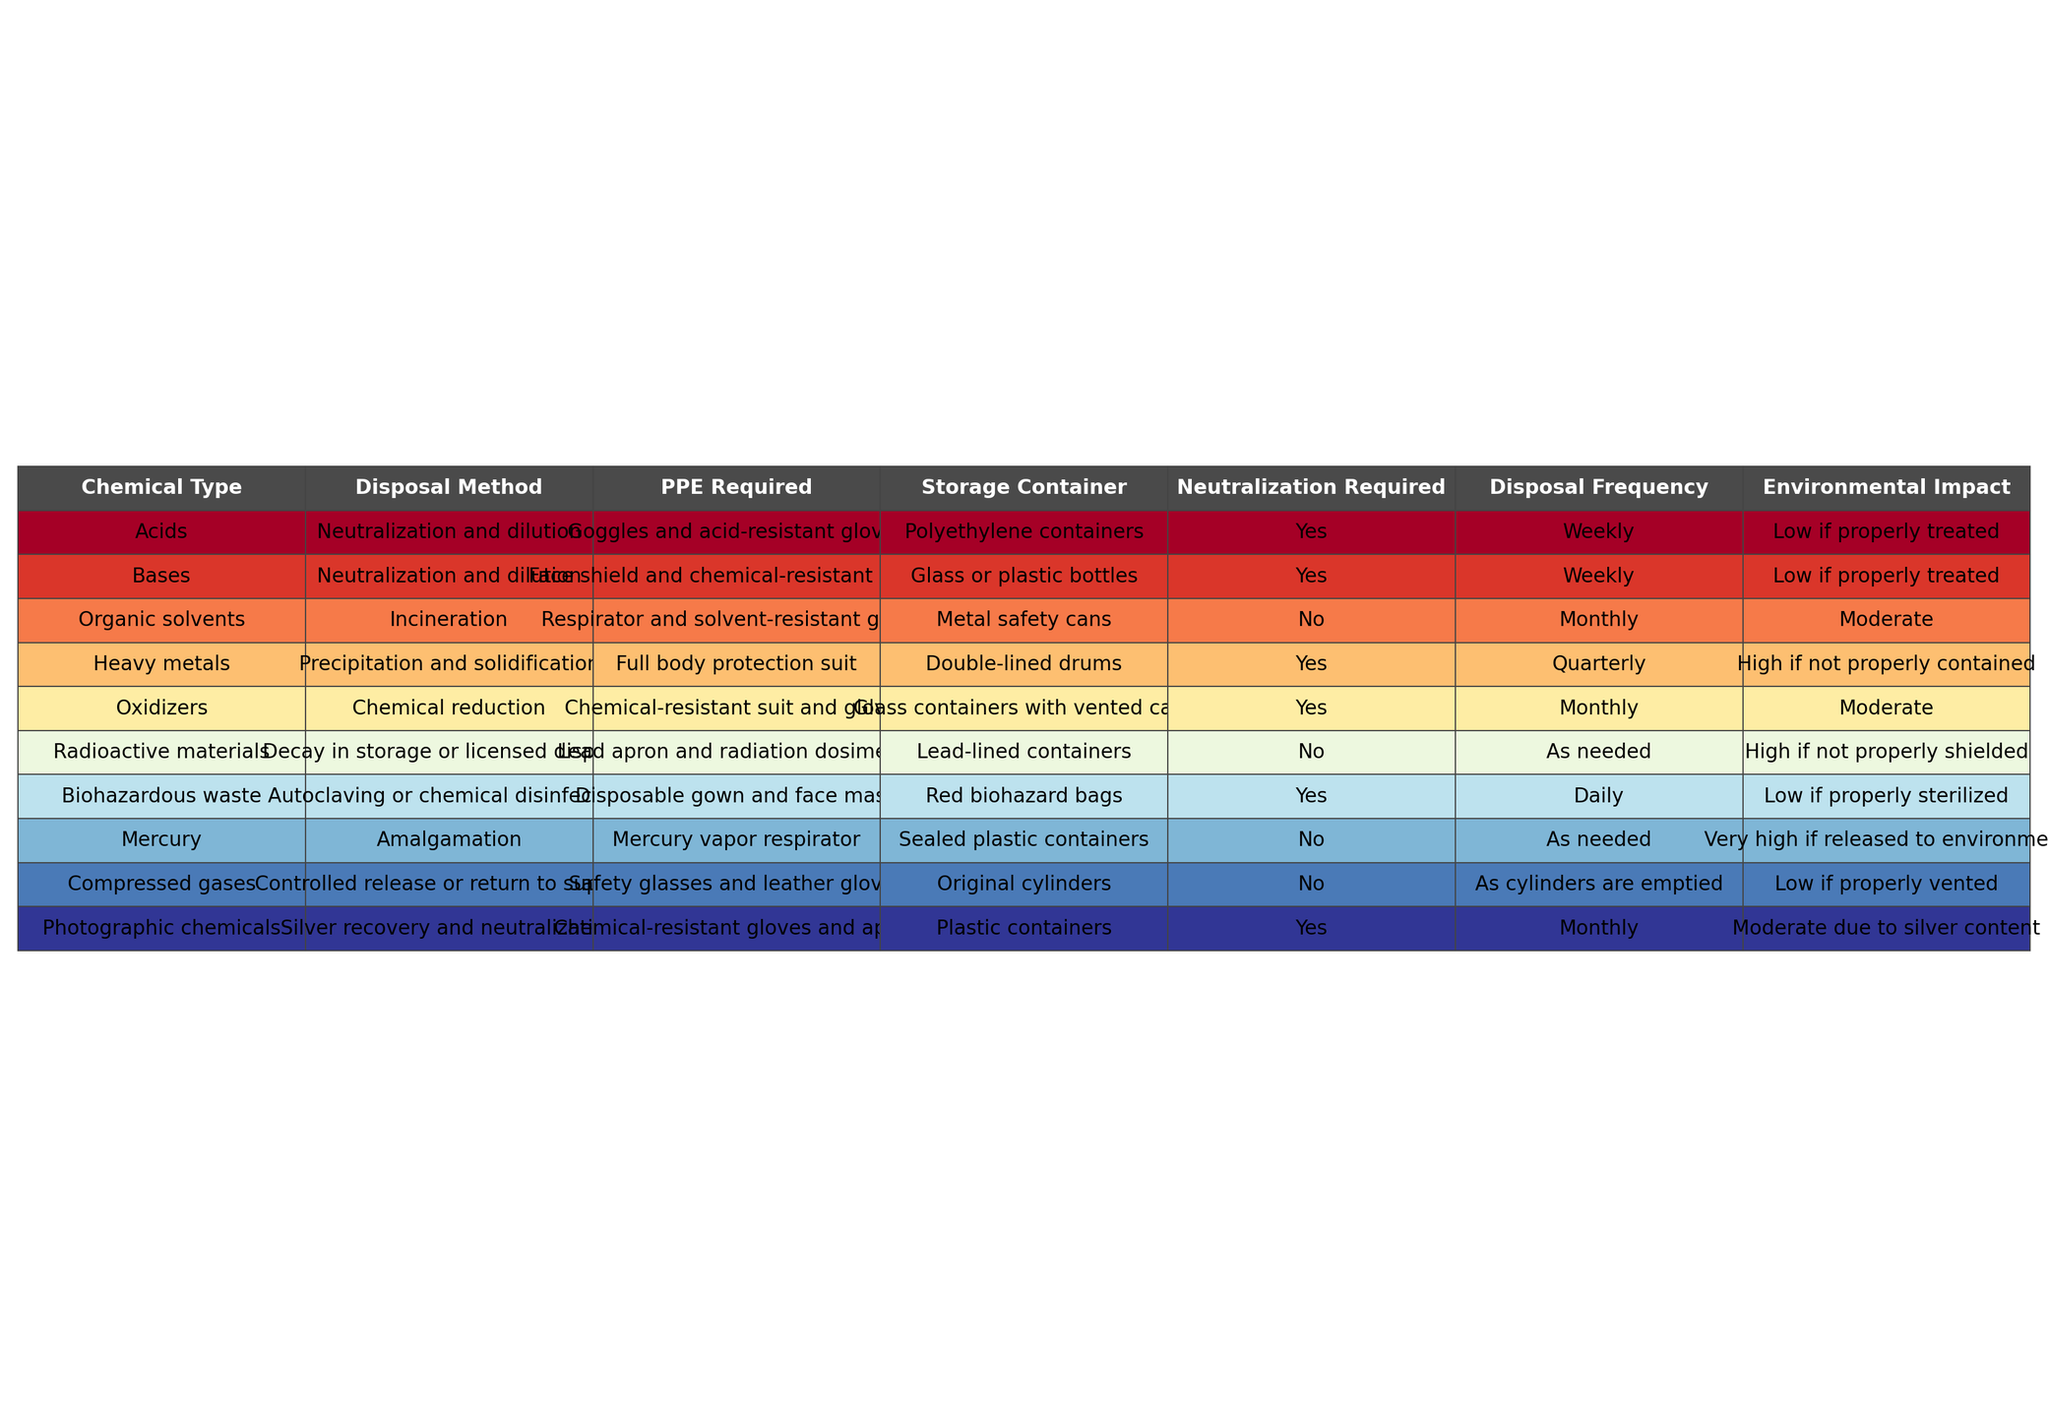What disposal method is used for organic solvents? The table indicates that organic solvents are disposed of through incineration.
Answer: Incineration What is the required PPE for handling heavy metals? The table lists that heavy metals require a full body protection suit as personal protective equipment.
Answer: Full body protection suit How often should acids be disposed of? According to the table, acids need to be disposed of weekly.
Answer: Weekly Are any disposal methods listed as requiring neutralization? The table shows that several chemicals, including acids, bases, oxidizers, and biohazardous waste, require neutralization as part of their disposal methods.
Answer: Yes Which type of chemical has the highest environmental impact if not properly contained? The table states that heavy metals have a high environmental impact if not properly contained.
Answer: Heavy metals What is the disposal frequency for photographic chemicals? The table indicates that the disposal frequency for photographic chemicals is monthly.
Answer: Monthly Which chemicals do not require neutralization during disposal? The table specifies that organic solvents, radioactive materials, mercury, and compressed gases do not require neutralization.
Answer: Organic solvents, radioactive materials, mercury, compressed gases What type of storage container is recommended for disposing of bases? It is noted in the table that bases should be disposed of in glass or plastic bottles.
Answer: Glass or plastic bottles If a laboratory has both heavy metals and biohazardous waste to dispose of, which should be disposed of more frequently? The table highlights that biohazardous waste should be disposed of daily, while heavy metals are disposed of quarterly, making biohazardous waste the more frequently disposed type.
Answer: Biohazardous waste What PPE is required for dealing with radioactive materials? The table lists that a lead apron and radiation dosimeter are required for handling radioactive materials.
Answer: Lead apron and radiation dosimeter What are the disposal protocols for compressed gases? The table indicates that compressed gases should be released in a controlled manner or returned to the supplier, following safety precautions including the use of safety glasses and leather gloves.
Answer: Controlled release or return to supplier 